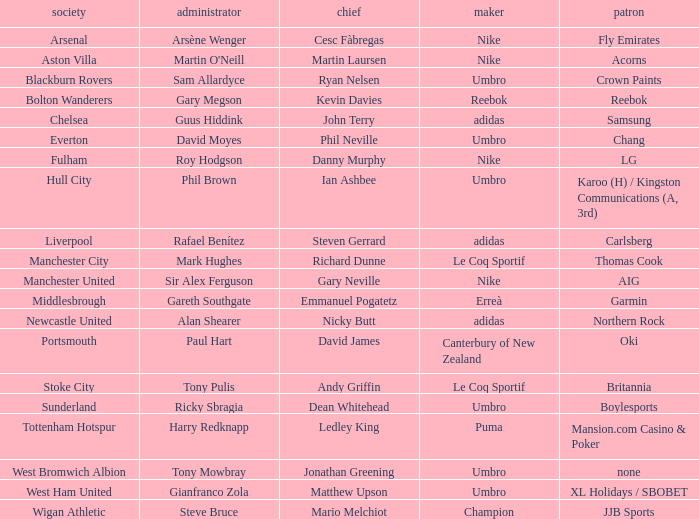What Premier League Manager has an Adidas sponsor and a Newcastle United club? Alan Shearer. 